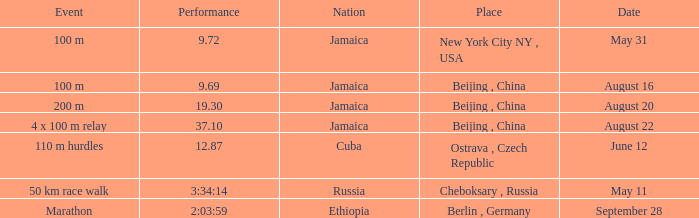Which location witnessed a 1 Beijing , China. 